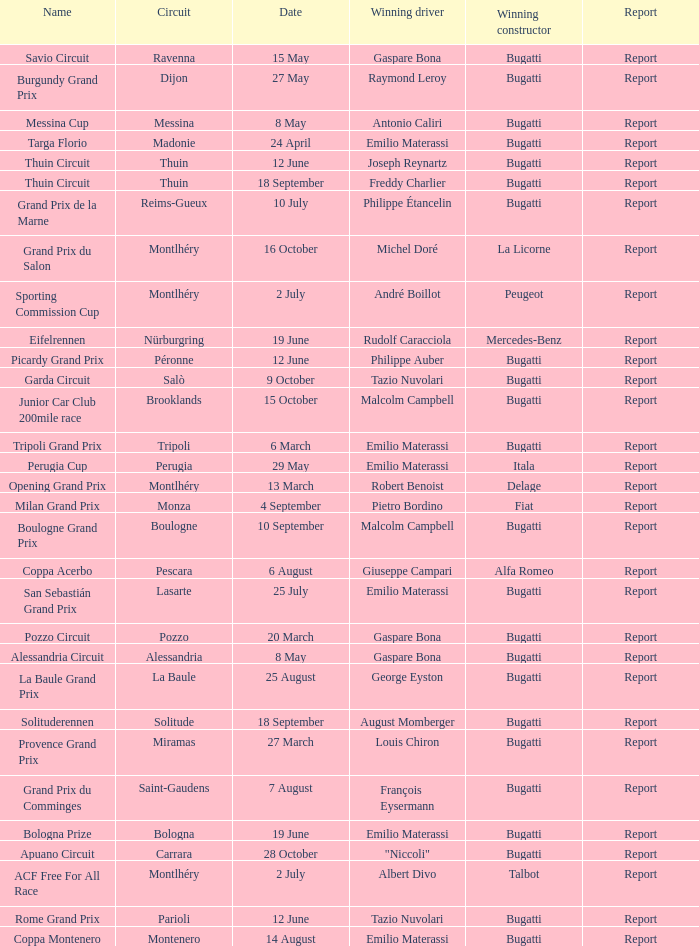Who was the winning constructor of the Grand Prix Du Salon ? La Licorne. 